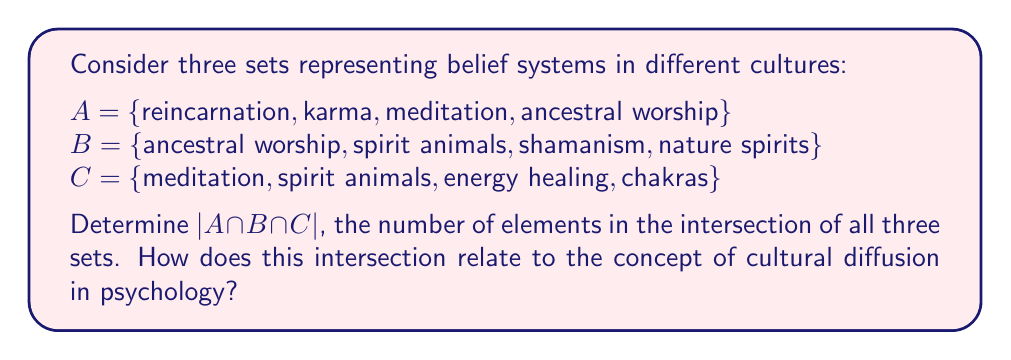Teach me how to tackle this problem. To solve this problem, we need to follow these steps:

1. Identify the elements that are common to all three sets.
2. Count the number of these common elements.

Let's examine each set:

A = {reincarnation, karma, meditation, ancestral worship}
B = {ancestral worship, spirit animals, shamanism, nature spirits}
C = {meditation, spirit animals, energy healing, chakras}

We can see that:
- "ancestral worship" is in A and B, but not in C
- "meditation" is in A and C, but not in B
- "spirit animals" is in B and C, but not in A

There are no elements that appear in all three sets.

Therefore, $A \cap B \cap C = \{\}$ (the empty set)

The number of elements in the empty set is 0, so $|A \cap B \cap C| = 0$.

From a cultural psychology perspective, this result is interesting. Despite these belief systems having some overlapping elements when compared pairwise, there is no single belief that is common to all three systems in this example. This illustrates the diversity of spiritual beliefs across cultures.

However, the existence of elements shared between pairs of sets (like "ancestral worship" or "spirit animals") could be seen as evidence of cultural diffusion - the spread of cultural beliefs and practices from one society to another. This concept is crucial in understanding how different cultures influence each other and how certain spiritual beliefs may transcend cultural boundaries.

The empty intersection doesn't mean these cultures are entirely dissimilar. Rather, it highlights the complexity of cultural belief systems and the nuanced ways in which they may relate to one another, a topic of great interest in cultural psychology.
Answer: $|A \cap B \cap C| = 0$ 